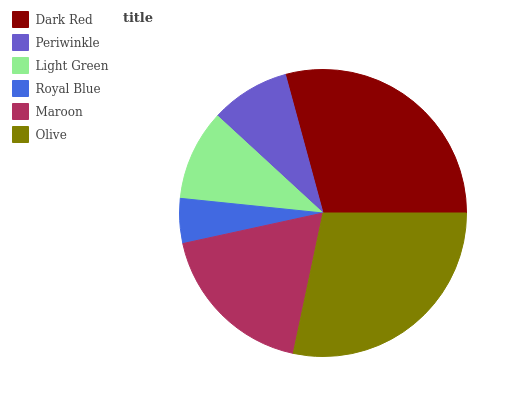Is Royal Blue the minimum?
Answer yes or no. Yes. Is Dark Red the maximum?
Answer yes or no. Yes. Is Periwinkle the minimum?
Answer yes or no. No. Is Periwinkle the maximum?
Answer yes or no. No. Is Dark Red greater than Periwinkle?
Answer yes or no. Yes. Is Periwinkle less than Dark Red?
Answer yes or no. Yes. Is Periwinkle greater than Dark Red?
Answer yes or no. No. Is Dark Red less than Periwinkle?
Answer yes or no. No. Is Maroon the high median?
Answer yes or no. Yes. Is Light Green the low median?
Answer yes or no. Yes. Is Royal Blue the high median?
Answer yes or no. No. Is Maroon the low median?
Answer yes or no. No. 